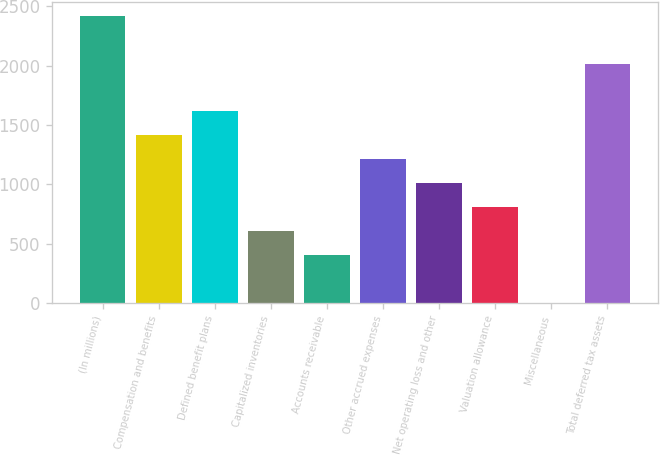Convert chart. <chart><loc_0><loc_0><loc_500><loc_500><bar_chart><fcel>(In millions)<fcel>Compensation and benefits<fcel>Defined benefit plans<fcel>Capitalized inventories<fcel>Accounts receivable<fcel>Other accrued expenses<fcel>Net operating loss and other<fcel>Valuation allowance<fcel>Miscellaneous<fcel>Total deferred tax assets<nl><fcel>2418.7<fcel>1411.95<fcel>1613.3<fcel>606.55<fcel>405.2<fcel>1210.6<fcel>1009.25<fcel>807.9<fcel>2.5<fcel>2016<nl></chart> 